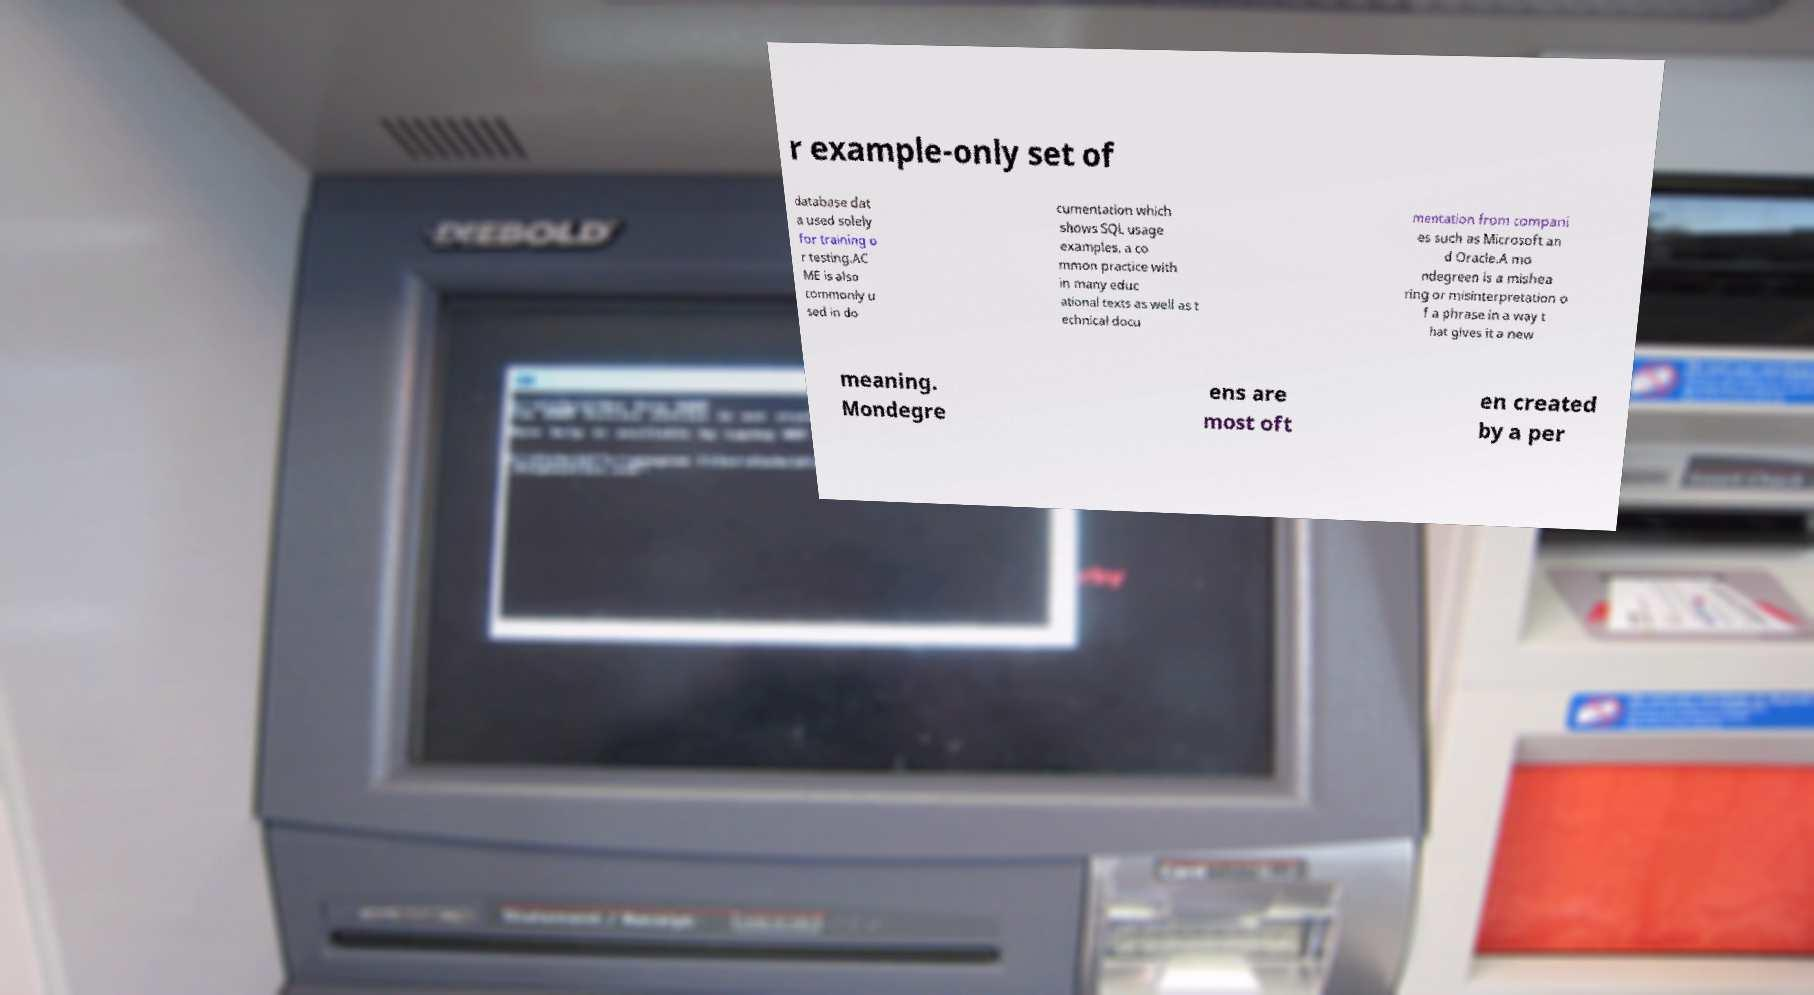Can you accurately transcribe the text from the provided image for me? r example-only set of database dat a used solely for training o r testing.AC ME is also commonly u sed in do cumentation which shows SQL usage examples, a co mmon practice with in many educ ational texts as well as t echnical docu mentation from compani es such as Microsoft an d Oracle.A mo ndegreen is a mishea ring or misinterpretation o f a phrase in a way t hat gives it a new meaning. Mondegre ens are most oft en created by a per 